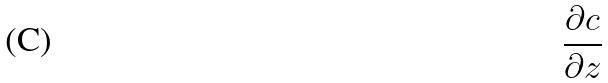Convert formula to latex. <formula><loc_0><loc_0><loc_500><loc_500>\frac { \partial c } { \partial z }</formula> 